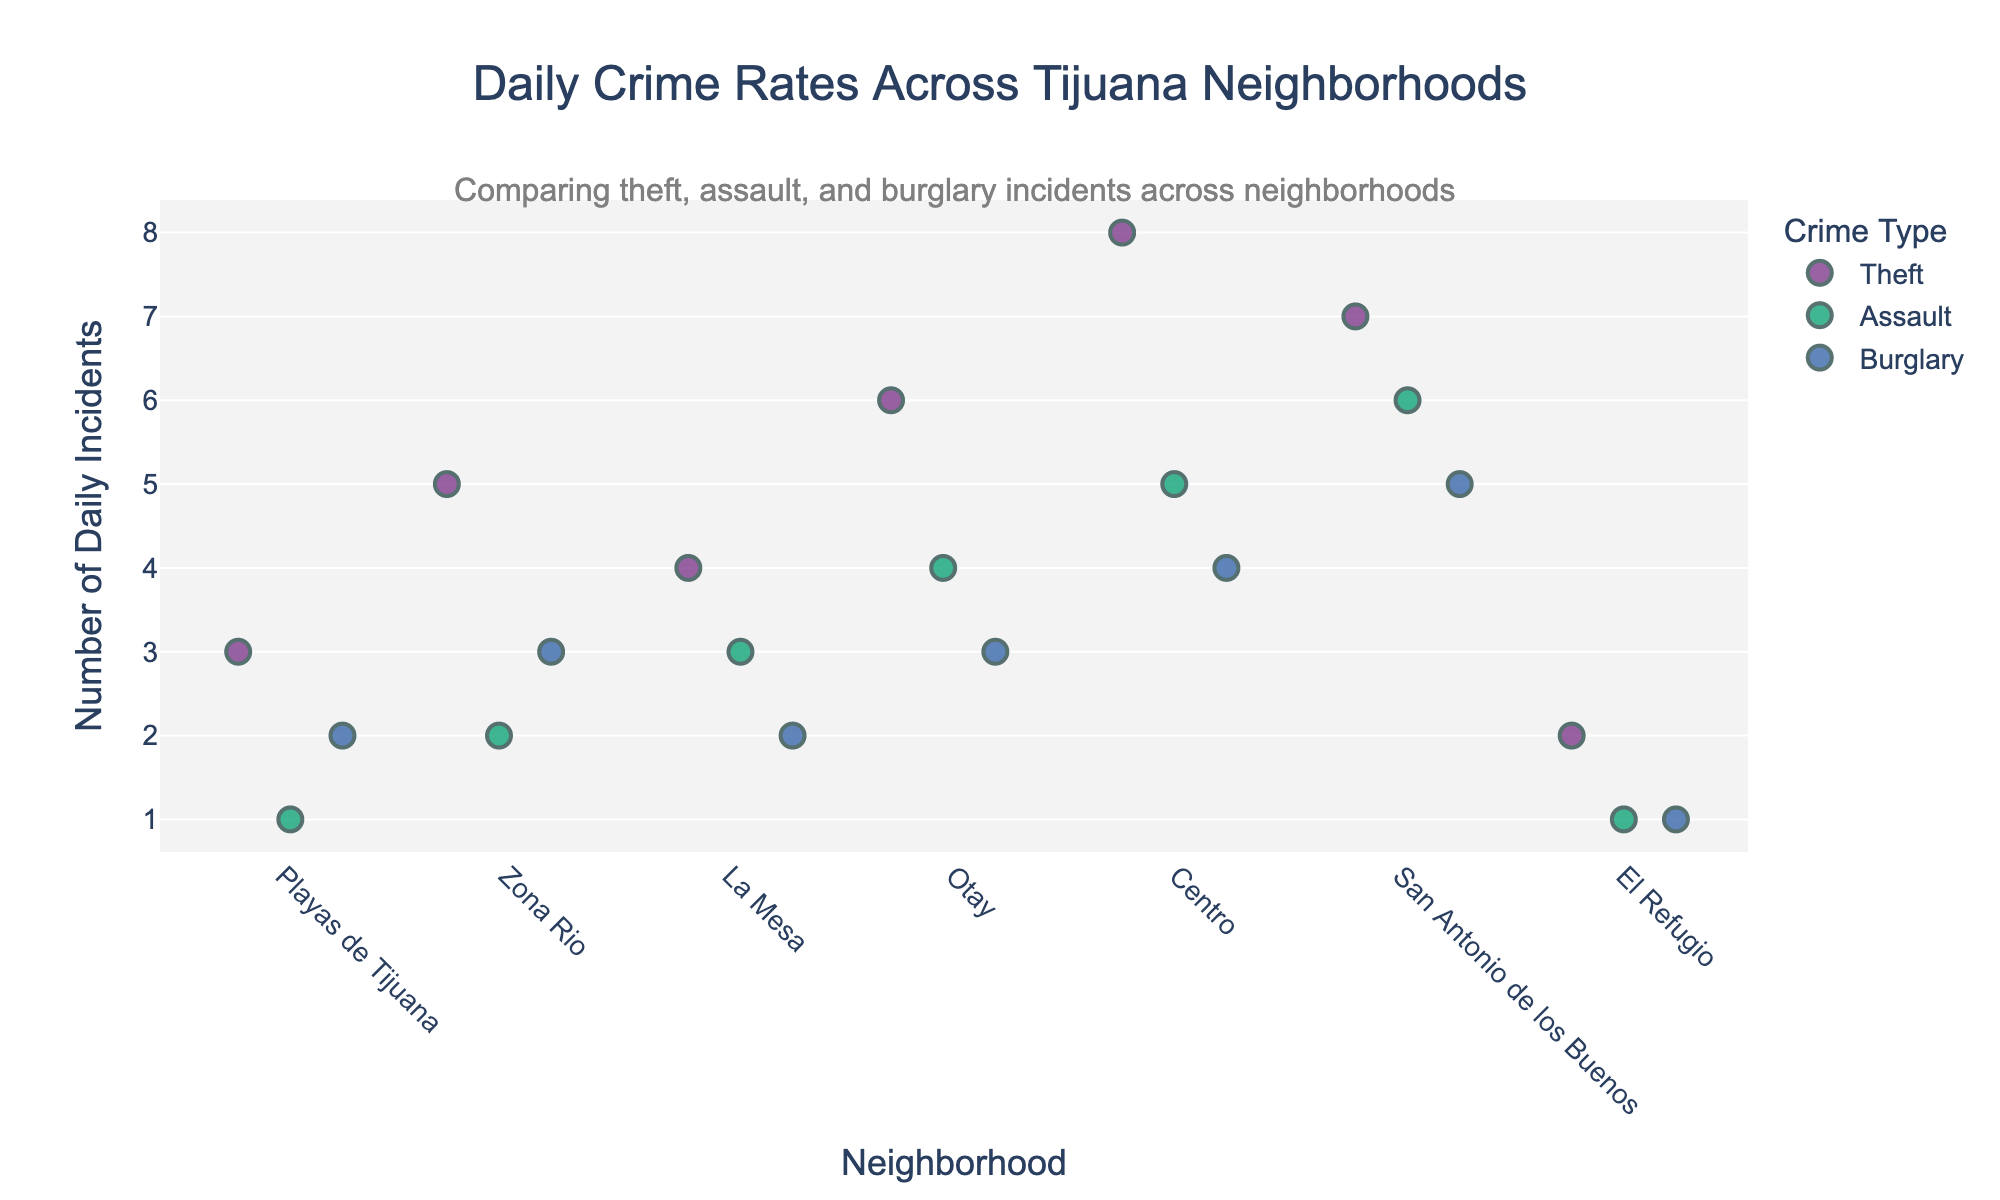Which neighborhood has the highest number of daily theft incidents? Refer to the strip plot and identify the neighborhood with the highest value for theft incidents. Centro has 8 theft incidents.
Answer: Centro What is the range of daily assault incidents across all neighborhoods? To find the range, locate the minimum and maximum values for the assault incidents. The minimum is 1 (El Refugio) and the maximum is 6 (San Antonio de los Buenos). Hence, the range is 6 - 1 = 5.
Answer: 5 Which crime type is most common in Otay? Identify the crime type with the highest number of incidents in Otay from the strip plot. Theft has the highest number with 6 incidents.
Answer: Theft How do burglary incidents in Playas de Tijuana compare to those in Zona Rio? Compare the daily incidents for burglary between Playas de Tijuana and Zona Rio. Playas de Tijuana has 2, and Zona Rio has 3. Zona Rio has one more incident than Playas de Tijuana.
Answer: Zona Rio has one more Which neighborhood has the least amount of daily crime incidents overall? Sum the daily incidents for all crime types in each neighborhood and find the lowest total. El Refugio has 2 (theft) + 1 (assault) + 1 (burglary) = 4 incidents in total, the lowest.
Answer: El Refugio Are there any neighborhoods where the burglary incident rate is the highest crime type? Look at the strip plot to check if any neighborhood has the highest incident rate for burglary above other crimes. No neighborhood has burglary as the highest incident rate.
Answer: No What is the average number of daily incidents for theft across all neighborhoods? Sum all theft incidents and divide by the number of neighborhoods. (3 + 5 + 4 + 6 + 8 + 7 + 2) = 35 incidents. There are 7 neighborhoods, so 35/7 = 5 average daily incidents.
Answer: 5 Which neighborhood has the widest spread of daily incidents for each crime type? Identify the total range (max - min) of daily incidents for each neighborhood. Find the neighborhood with the highest total range. Centro (8 for theft, 5 for assault, 4 for burglary) has the highest spread (8 - 4 = 4).
Answer: Centro Are there any crime types that consistently have lower incidents than others across neighborhoods? Compare the incident rates across all crime types and neighborhoods. Assault tends to have lower incident numbers compared to theft and burglary.
Answer: Assault What is the combined total of daily crime incidents for San Antonio de los Buenos? Sum the daily incidents for theft, assault, and burglary in San Antonio de los Buenos. 7 (theft) + 6 (assault) + 5 (burglary) = 18 incidents in total.
Answer: 18 